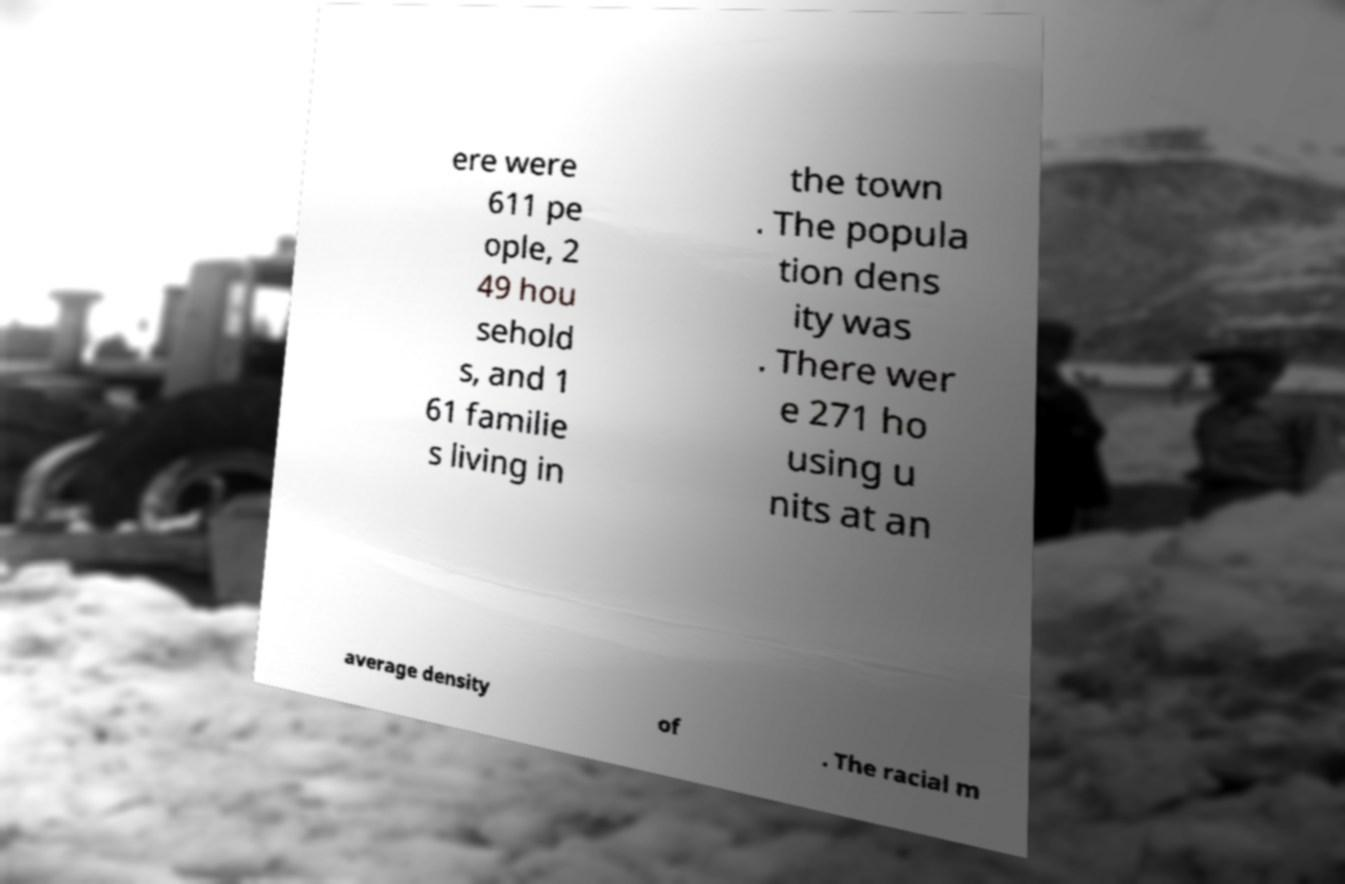What messages or text are displayed in this image? I need them in a readable, typed format. ere were 611 pe ople, 2 49 hou sehold s, and 1 61 familie s living in the town . The popula tion dens ity was . There wer e 271 ho using u nits at an average density of . The racial m 